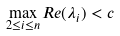<formula> <loc_0><loc_0><loc_500><loc_500>\max _ { 2 \leq i \leq n } { R e ( \lambda _ { i } ) } < c</formula> 